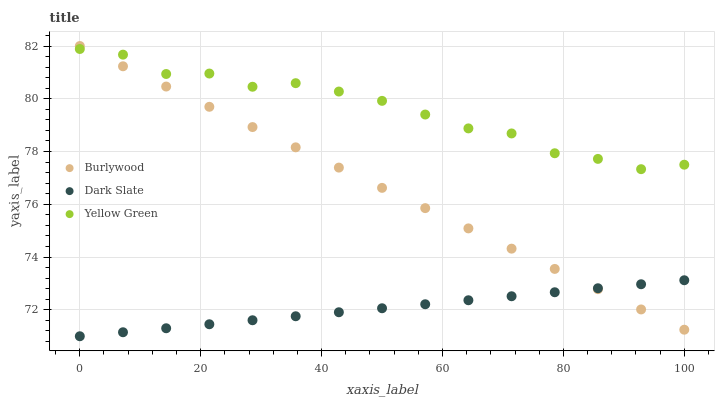Does Dark Slate have the minimum area under the curve?
Answer yes or no. Yes. Does Yellow Green have the maximum area under the curve?
Answer yes or no. Yes. Does Yellow Green have the minimum area under the curve?
Answer yes or no. No. Does Dark Slate have the maximum area under the curve?
Answer yes or no. No. Is Burlywood the smoothest?
Answer yes or no. Yes. Is Yellow Green the roughest?
Answer yes or no. Yes. Is Dark Slate the smoothest?
Answer yes or no. No. Is Dark Slate the roughest?
Answer yes or no. No. Does Dark Slate have the lowest value?
Answer yes or no. Yes. Does Yellow Green have the lowest value?
Answer yes or no. No. Does Burlywood have the highest value?
Answer yes or no. Yes. Does Yellow Green have the highest value?
Answer yes or no. No. Is Dark Slate less than Yellow Green?
Answer yes or no. Yes. Is Yellow Green greater than Dark Slate?
Answer yes or no. Yes. Does Burlywood intersect Yellow Green?
Answer yes or no. Yes. Is Burlywood less than Yellow Green?
Answer yes or no. No. Is Burlywood greater than Yellow Green?
Answer yes or no. No. Does Dark Slate intersect Yellow Green?
Answer yes or no. No. 